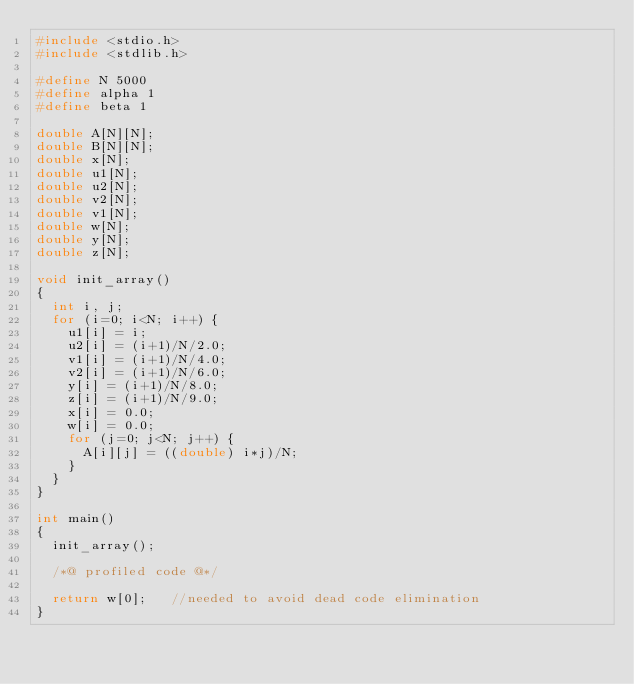<code> <loc_0><loc_0><loc_500><loc_500><_C_>#include <stdio.h> 
#include <stdlib.h> 

#define N 5000
#define alpha 1
#define beta 1

double A[N][N];
double B[N][N];
double x[N];
double u1[N];
double u2[N];
double v2[N];
double v1[N];
double w[N];
double y[N];
double z[N];

void init_array()  
{  
  int i, j;
  for (i=0; i<N; i++) {
    u1[i] = i;
    u2[i] = (i+1)/N/2.0;
    v1[i] = (i+1)/N/4.0;
    v2[i] = (i+1)/N/6.0;
    y[i] = (i+1)/N/8.0;
    z[i] = (i+1)/N/9.0;
    x[i] = 0.0;
    w[i] = 0.0;
    for (j=0; j<N; j++) {
      A[i][j] = ((double) i*j)/N;
    }
  }
}  

int main() 
{ 
  init_array(); 
 
  /*@ profiled code @*/ 
 
  return w[0];   //needed to avoid dead code elimination 
} 
</code> 